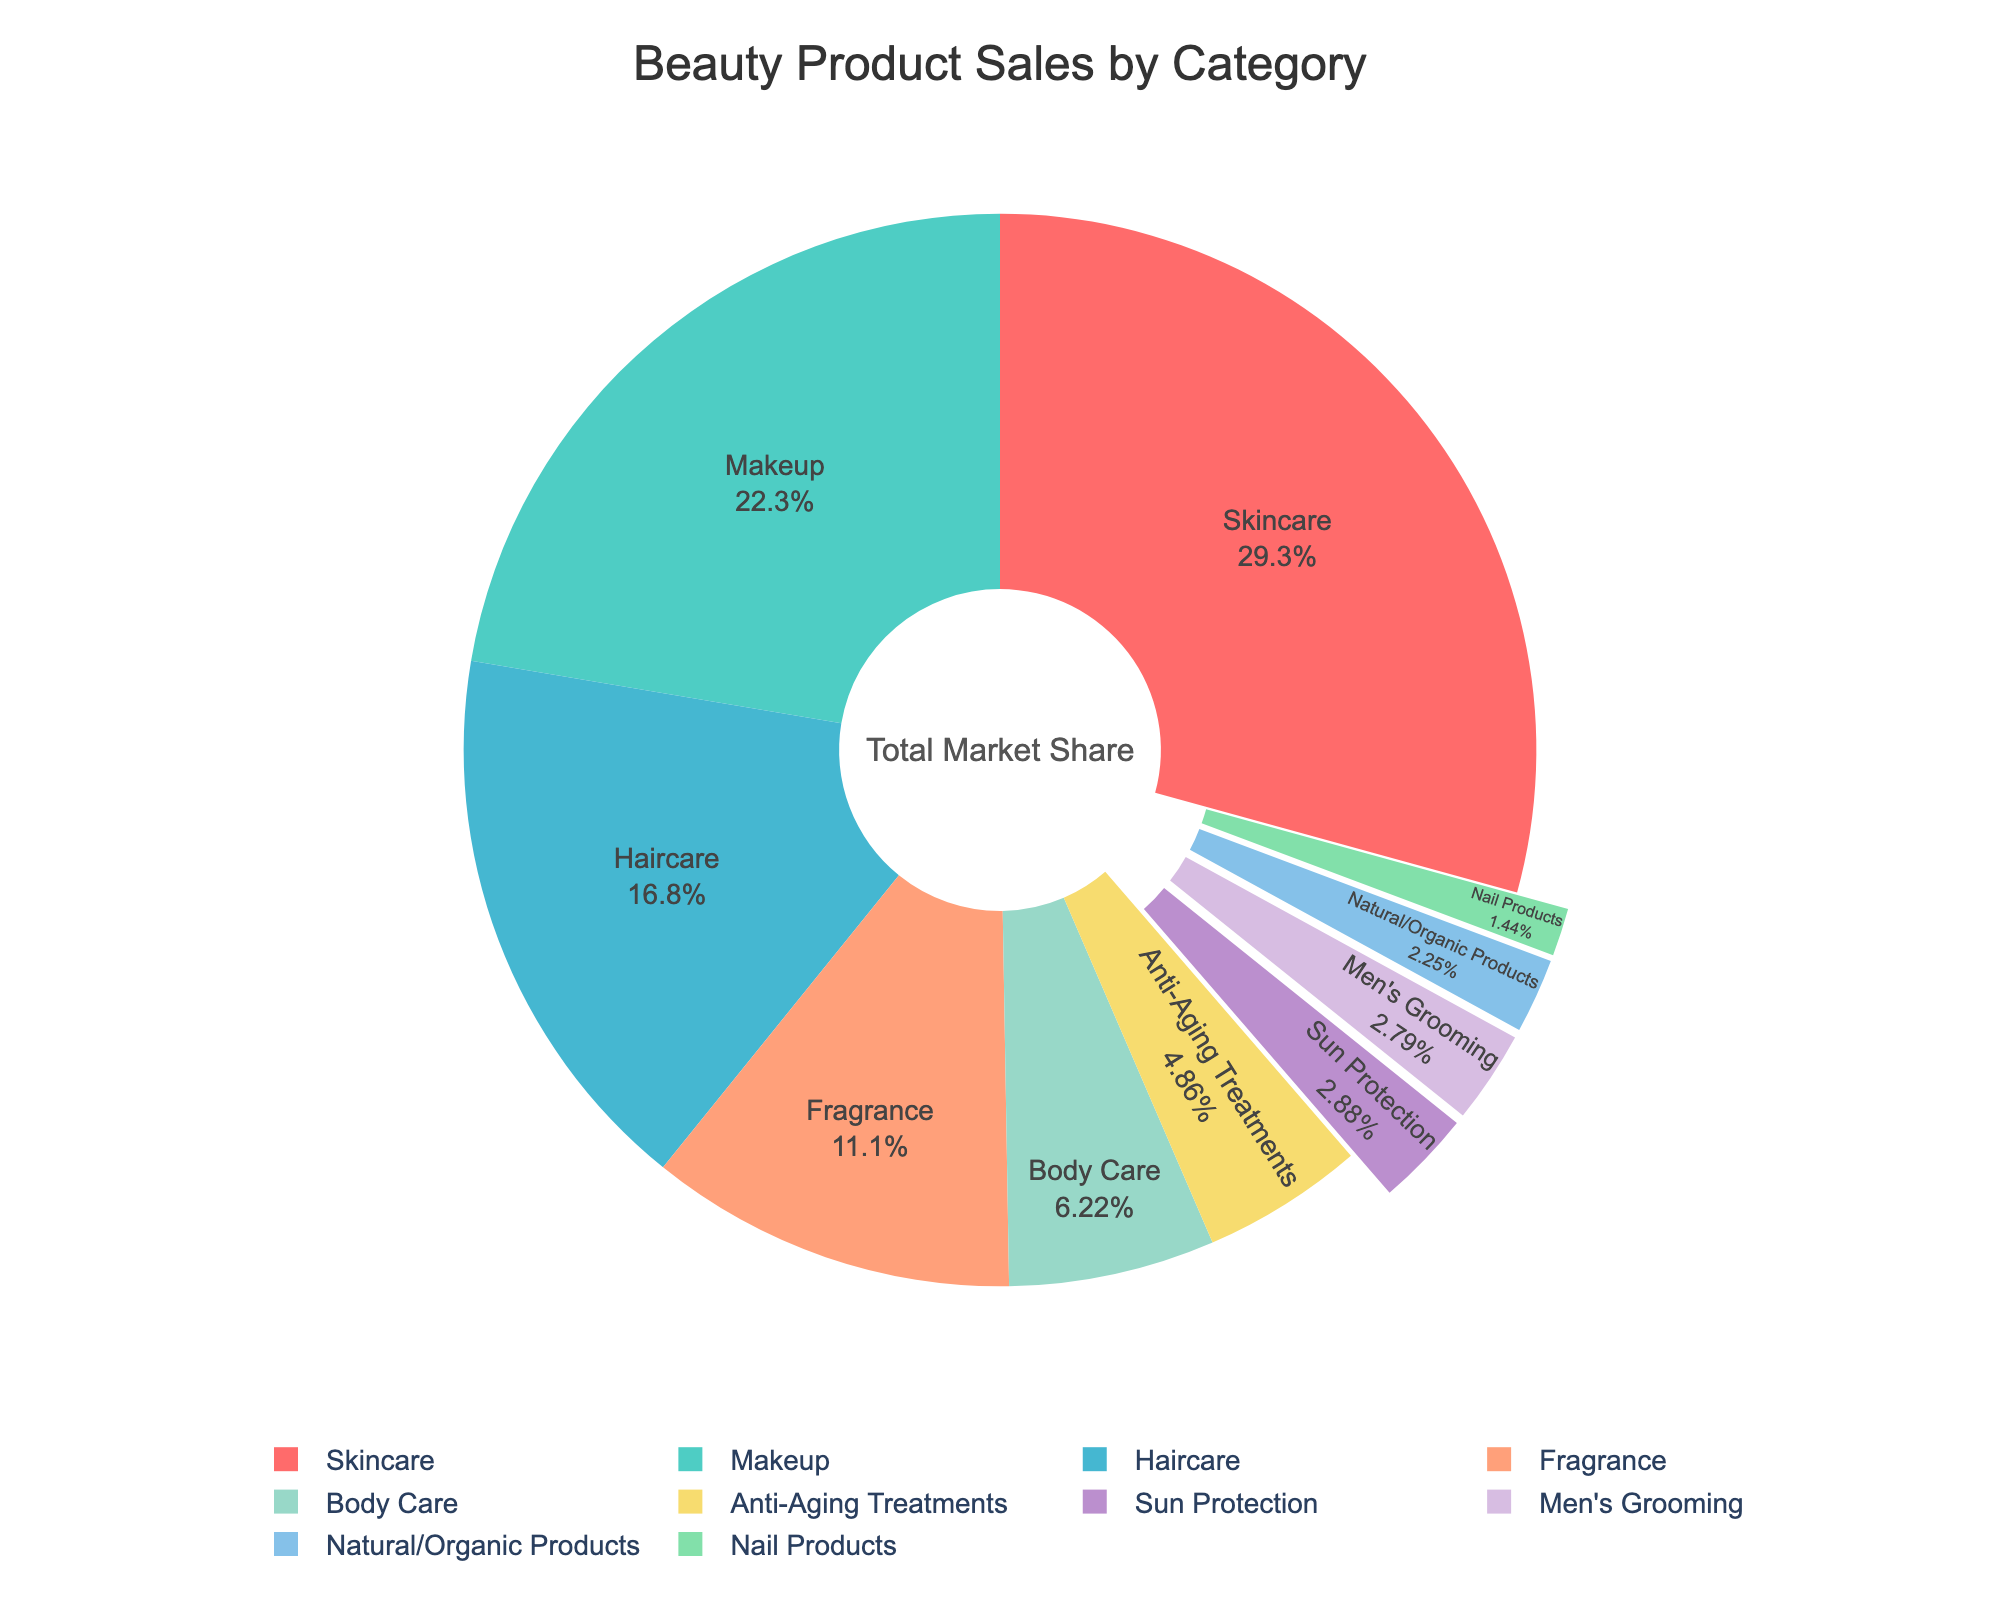What category has the highest percentage of sales? Look at the pie chart and identify the segment with the largest percentage value. The Skincare section is the largest.
Answer: Skincare Which category has a slightly higher percentage, Fragrance or Body Care? Compare the percentage labels for Fragrance (12.3%) and Body Care (6.9%). Fragrance is higher.
Answer: Fragrance Are there any categories with more than 30% market share? Check all the percentage values displayed on the pie chart. Skincare is the only category with more than 30%.
Answer: Yes, Skincare What's the total percentage of sales for Skincare, Makeup, and Haircare combined? Add the percentages of Skincare (32.5%), Makeup (24.8%), and Haircare (18.7%). 32.5 + 24.8 + 18.7 = 76.0%
Answer: 76.0% Which category has the smallest market share, and what is its percentage? Look for the category with the smallest percentage value displayed on the pie chart. Nail Products have the smallest market share with 1.6%.
Answer: Nail Products, 1.6% How much larger is the Skincare segment compared to Makeup? Subtract the Makeup percentage (24.8%) from the Skincare percentage (32.5%). 32.5 - 24.8 = 7.7%
Answer: 7.7% What is the combined market share of categories under 5%? Add the percentages of Sun Protection (3.2%), Men's Grooming (3.1%), Natural/Organic Products (2.5%), and Nail Products (1.6%). 3.2 + 3.1 + 2.5 + 1.6 = 10.4%
Answer: 10.4% What is the difference in market share between the largest and smallest segments? Subtract the smallest segment (Nail Products, 1.6%) from the largest segment (Skincare, 32.5%). 32.5 - 1.6 = 30.9%
Answer: 30.9% Is the sum of the percentages for Body Care and Anti-Aging Treatments greater than the percentage for Fragrance? Add the percentages of Body Care (6.9%) and Anti-Aging Treatments (5.4%), then compare the sum (6.9 + 5.4 = 12.3%) to the percentage for Fragrance (12.3%). 12.3% equals 12.3%.
Answer: No, it's equal 